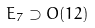Convert formula to latex. <formula><loc_0><loc_0><loc_500><loc_500>E _ { 7 } \supset O ( 1 2 )</formula> 